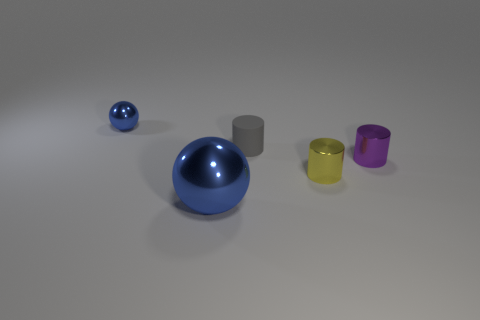Add 5 tiny balls. How many objects exist? 10 Subtract all spheres. How many objects are left? 3 Add 1 big blue metallic objects. How many big blue metallic objects are left? 2 Add 1 shiny cylinders. How many shiny cylinders exist? 3 Subtract 0 red balls. How many objects are left? 5 Subtract all small yellow rubber cylinders. Subtract all tiny gray matte things. How many objects are left? 4 